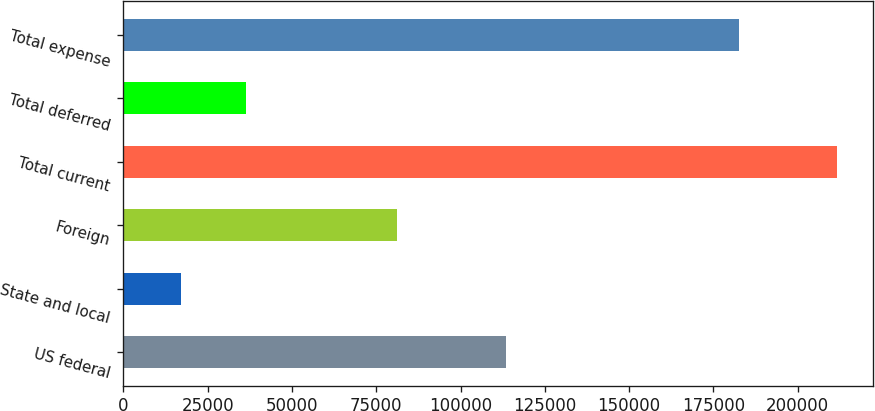Convert chart to OTSL. <chart><loc_0><loc_0><loc_500><loc_500><bar_chart><fcel>US federal<fcel>State and local<fcel>Foreign<fcel>Total current<fcel>Total deferred<fcel>Total expense<nl><fcel>113591<fcel>17037<fcel>81034<fcel>211662<fcel>36499.5<fcel>182516<nl></chart> 